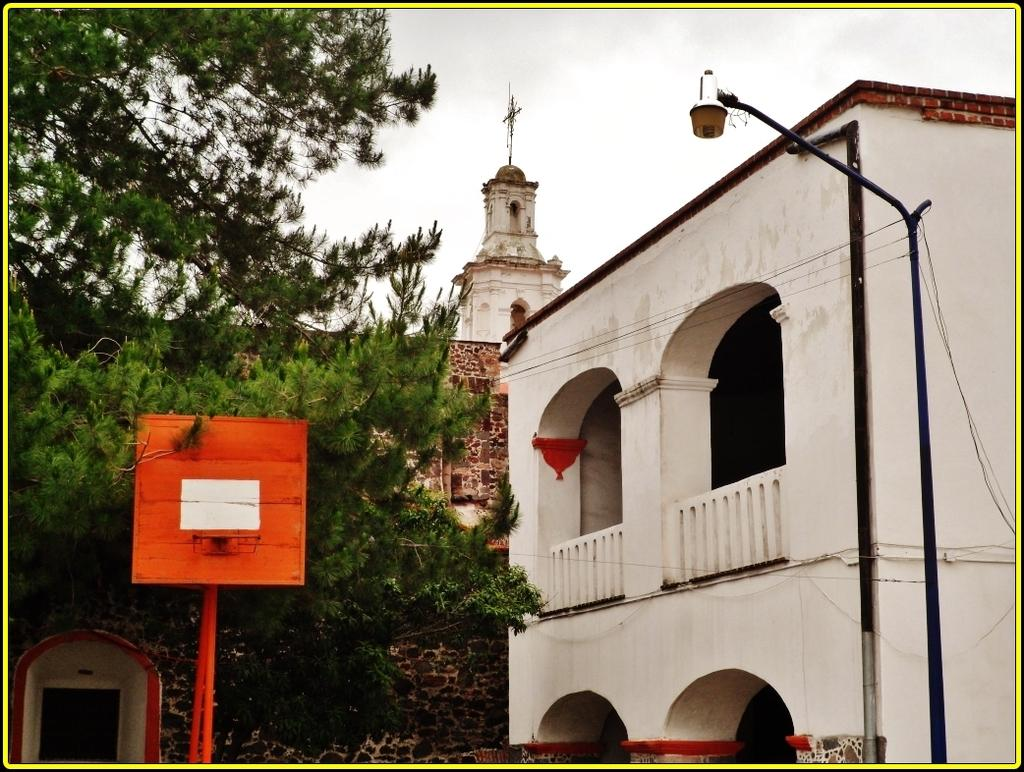What type of structures can be seen in the image? There are buildings in the image. What sports-related object is present in the image? There is a goal net in the image. Can you describe a specific architectural feature in the image? There is a door in the image. What type of lighting is present in the image? There is a street light in the image. What type of infrastructure can be seen in the image? There are wires in the image. What type of natural elements are present in the image? There are trees in the image. What is visible at the top of the image? The sky is visible at the top of the image. Based on the presence of the sky and the absence of artificial lighting, can you infer the time of day when the image was taken? The image is likely taken during the day. How much sugar is present in the image? There is no sugar present in the image. Can you see the friend of the person who took the image in the picture? There is no person visible in the image, so it is impossible to determine if a friend is present. Is there any quicksand visible in the image? There is no quicksand present in the image. 